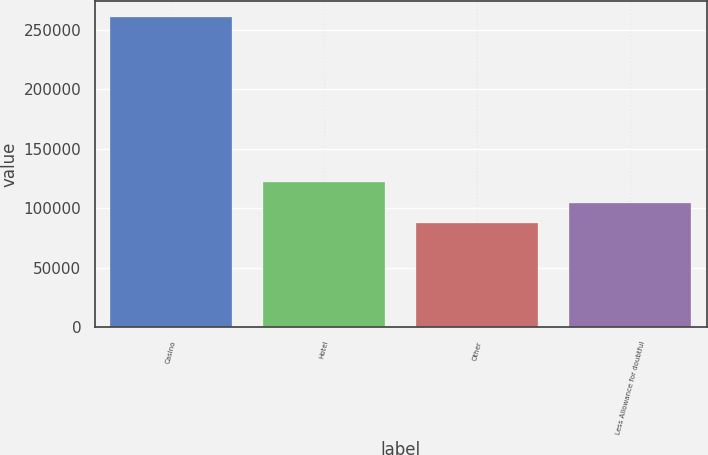<chart> <loc_0><loc_0><loc_500><loc_500><bar_chart><fcel>Casino<fcel>Hotel<fcel>Other<fcel>Less Allowance for doubtful<nl><fcel>261025<fcel>121937<fcel>87165<fcel>104551<nl></chart> 